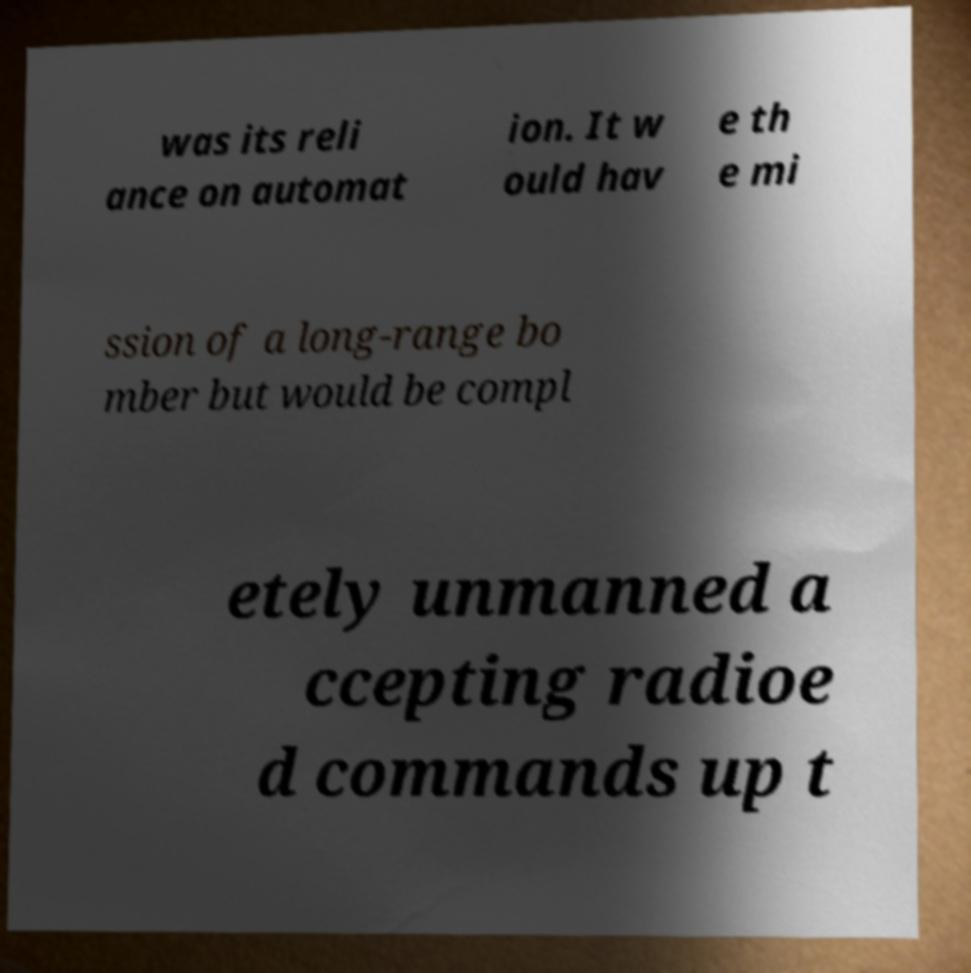For documentation purposes, I need the text within this image transcribed. Could you provide that? was its reli ance on automat ion. It w ould hav e th e mi ssion of a long-range bo mber but would be compl etely unmanned a ccepting radioe d commands up t 